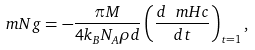Convert formula to latex. <formula><loc_0><loc_0><loc_500><loc_500>\ m N g = - \frac { \pi M } { 4 k _ { B } N _ { A } \rho d } \left ( \frac { d \ m H c } { d t } \right ) _ { t = 1 } ,</formula> 